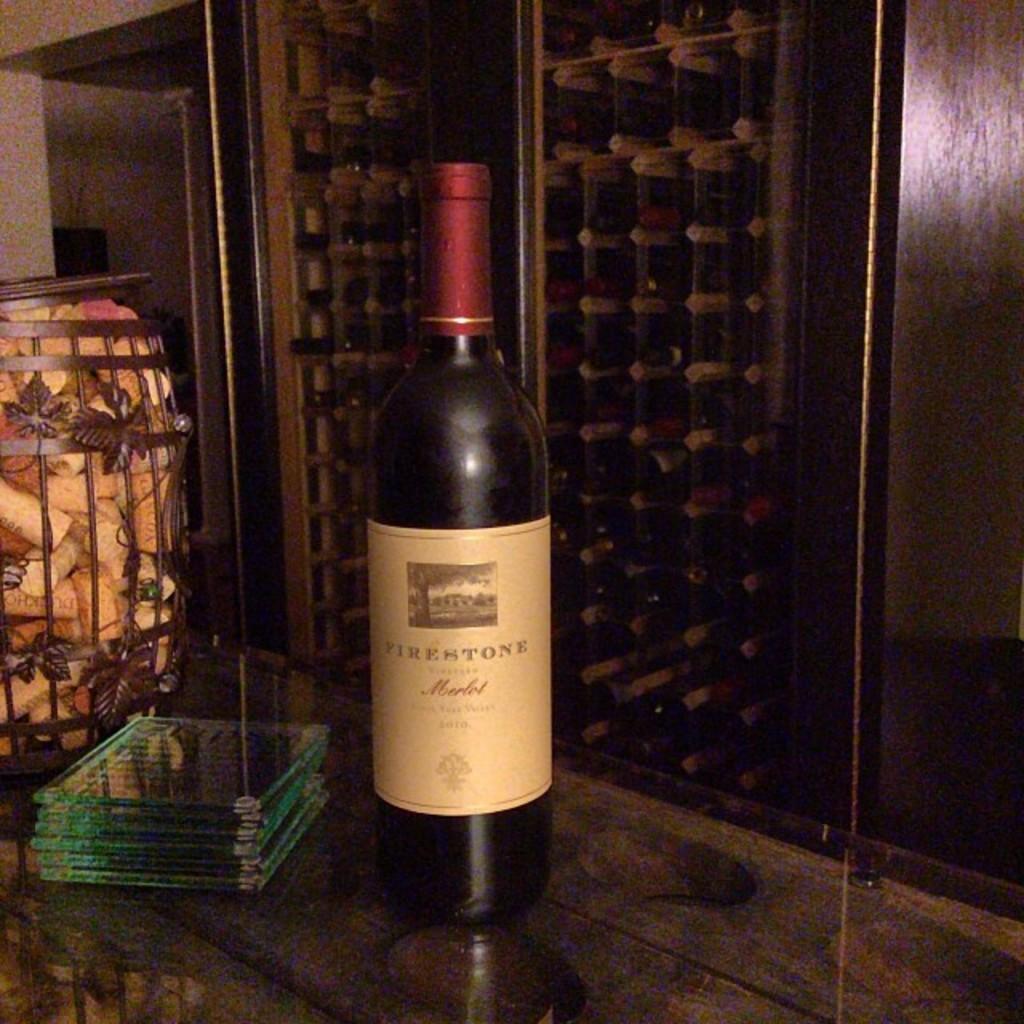What flavor of wine is this?
Your response must be concise. Merlot. 